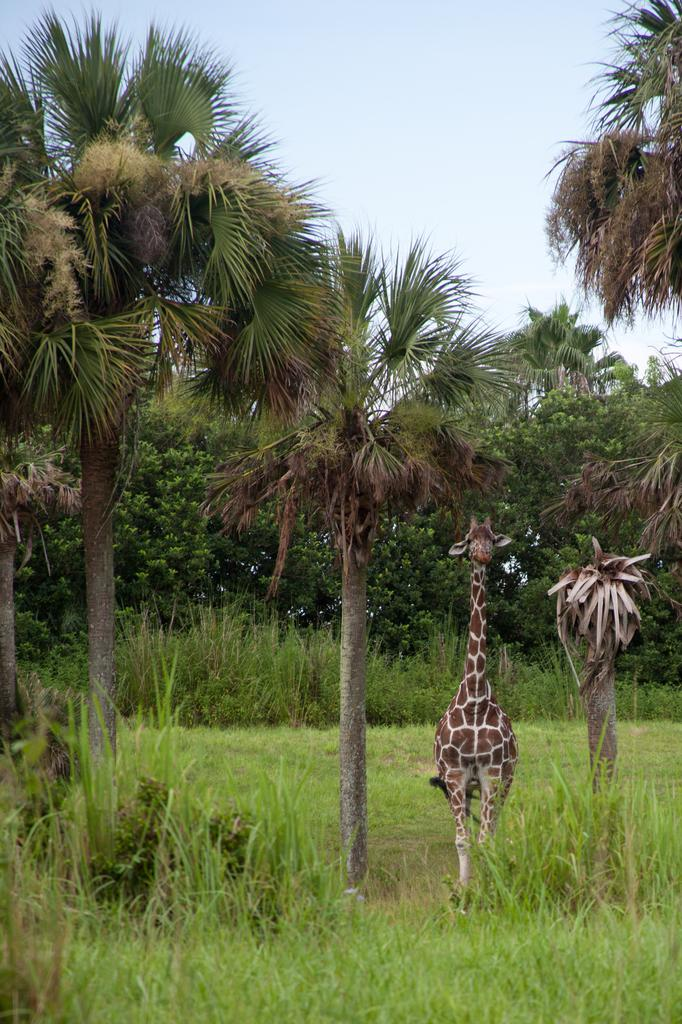What type of ground surface is visible in the image? There is grass on the ground in the image. What animal can be seen in the image? There is a giraffe in the image. What other types of vegetation are present in the image? There are plants and trees in the image. What can be seen above the vegetation in the image? The sky is visible in the image. What type of eggnog is being served in the image? There is no eggnog present in the image. What kind of drum is being played in the image? There is no drum present in the image. 